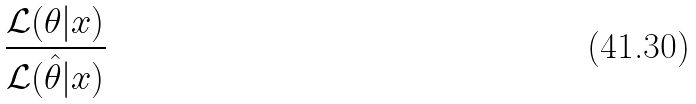Convert formula to latex. <formula><loc_0><loc_0><loc_500><loc_500>\frac { { \mathcal { L } } ( \theta | x ) } { { \mathcal { L } } ( { \hat { \theta } } | x ) }</formula> 